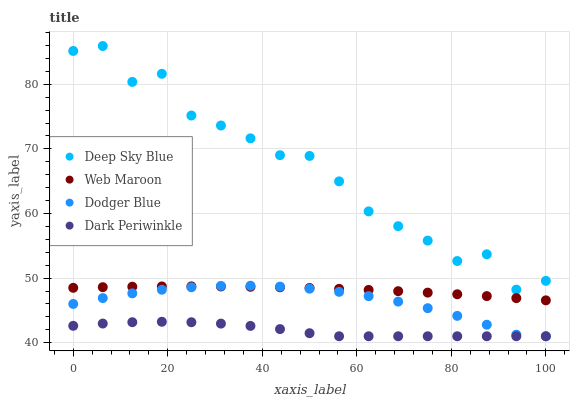Does Dark Periwinkle have the minimum area under the curve?
Answer yes or no. Yes. Does Deep Sky Blue have the maximum area under the curve?
Answer yes or no. Yes. Does Web Maroon have the minimum area under the curve?
Answer yes or no. No. Does Web Maroon have the maximum area under the curve?
Answer yes or no. No. Is Web Maroon the smoothest?
Answer yes or no. Yes. Is Deep Sky Blue the roughest?
Answer yes or no. Yes. Is Dark Periwinkle the smoothest?
Answer yes or no. No. Is Dark Periwinkle the roughest?
Answer yes or no. No. Does Dodger Blue have the lowest value?
Answer yes or no. Yes. Does Web Maroon have the lowest value?
Answer yes or no. No. Does Deep Sky Blue have the highest value?
Answer yes or no. Yes. Does Web Maroon have the highest value?
Answer yes or no. No. Is Web Maroon less than Deep Sky Blue?
Answer yes or no. Yes. Is Deep Sky Blue greater than Dark Periwinkle?
Answer yes or no. Yes. Does Web Maroon intersect Dodger Blue?
Answer yes or no. Yes. Is Web Maroon less than Dodger Blue?
Answer yes or no. No. Is Web Maroon greater than Dodger Blue?
Answer yes or no. No. Does Web Maroon intersect Deep Sky Blue?
Answer yes or no. No. 